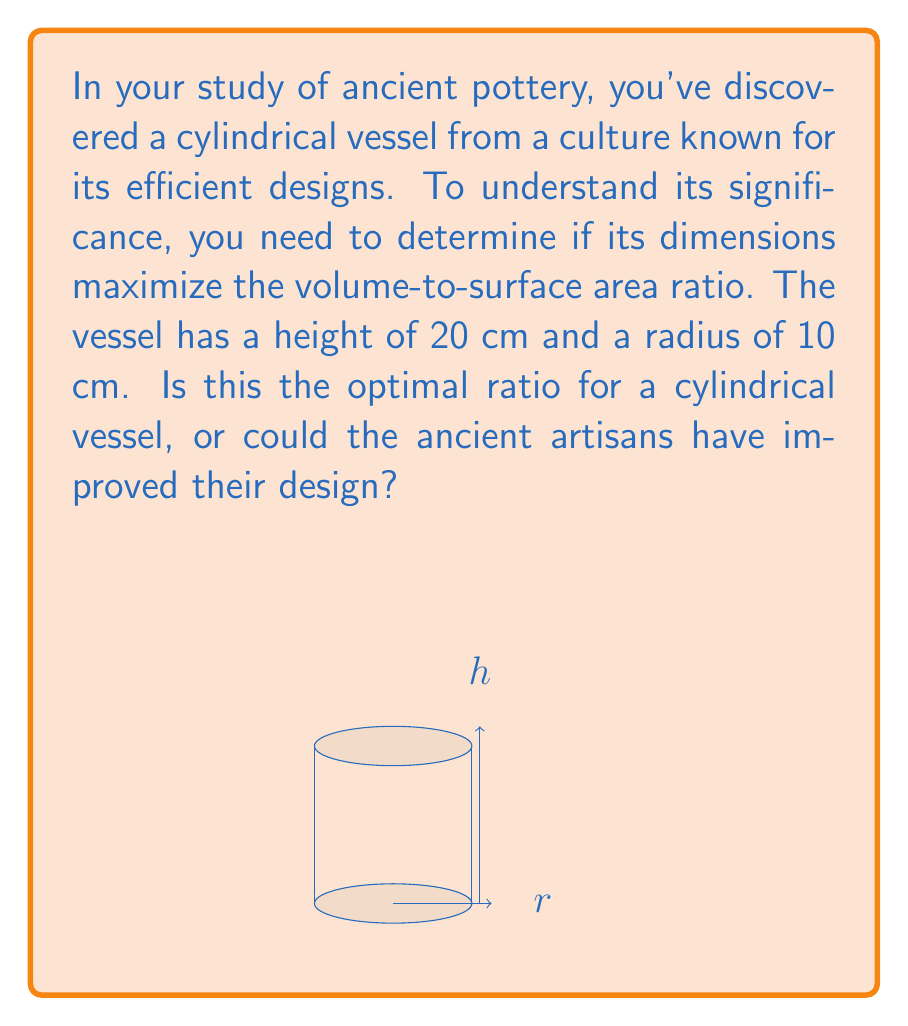Help me with this question. To solve this problem, we need to follow these steps:

1) First, let's recall the formulas for the volume and surface area of a cylinder:
   Volume: $V = \pi r^2 h$
   Surface Area: $SA = 2\pi r^2 + 2\pi r h$

2) The volume-to-surface area ratio is given by:
   $$\frac{V}{SA} = \frac{\pi r^2 h}{2\pi r^2 + 2\pi r h}$$

3) To find the optimal ratio, we need to maximize this function. In calculus, we would do this by finding where the derivative equals zero. However, there's a simpler method for cylinders.

4) It's known that for a cylinder to have the maximum volume-to-surface area ratio, its height must be equal to its diameter. In other words:
   $h = 2r$

5) Let's check if our vessel satisfies this condition:
   Height (h) = 20 cm
   Radius (r) = 10 cm
   
   Indeed, 20 = 2 * 10, so $h = 2r$

6) Therefore, this vessel already has the optimal dimensions for maximizing the volume-to-surface area ratio.

7) We can calculate the actual ratio:
   $$\frac{V}{SA} = \frac{\pi (10^2)(20)}{2\pi (10^2) + 2\pi (10)(20)} = \frac{2000\pi}{600\pi} = \frac{10}{3} \approx 3.33$$

This ratio is the maximum possible for a cylindrical vessel.
Answer: The vessel's dimensions are optimal; $h = 2r = 20$ cm maximizes the volume-to-surface area ratio at $\frac{10}{3}$. 